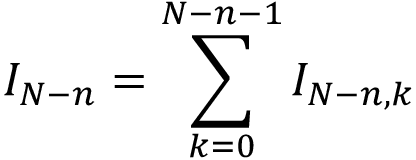<formula> <loc_0><loc_0><loc_500><loc_500>I _ { N - n } = \sum _ { k = 0 } ^ { N - n - 1 } I _ { N - n , k }</formula> 